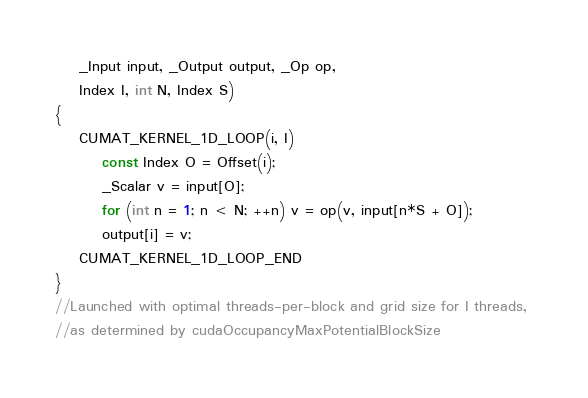<code> <loc_0><loc_0><loc_500><loc_500><_Cuda_>	_Input input, _Output output, _Op op,
	Index I, int N, Index S)
{
	CUMAT_KERNEL_1D_LOOP(i, I)
		const Index O = Offset(i);
		_Scalar v = input[O];
		for (int n = 1; n < N; ++n) v = op(v, input[n*S + O]);
		output[i] = v;
	CUMAT_KERNEL_1D_LOOP_END
}
//Launched with optimal threads-per-block and grid size for I threads, 
//as determined by cudaOccupancyMaxPotentialBlockSize</code> 